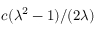<formula> <loc_0><loc_0><loc_500><loc_500>c ( \lambda ^ { 2 } - 1 ) / ( 2 \lambda )</formula> 